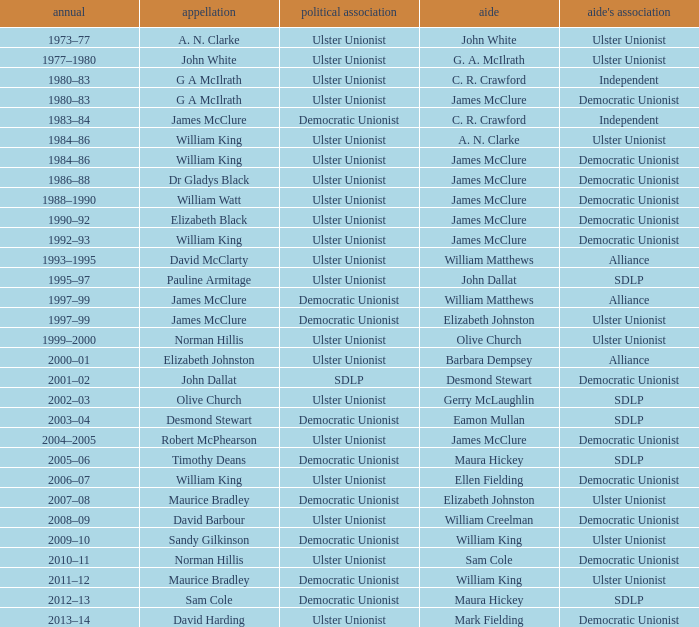What is the name of the deputy in 1992–93? James McClure. 